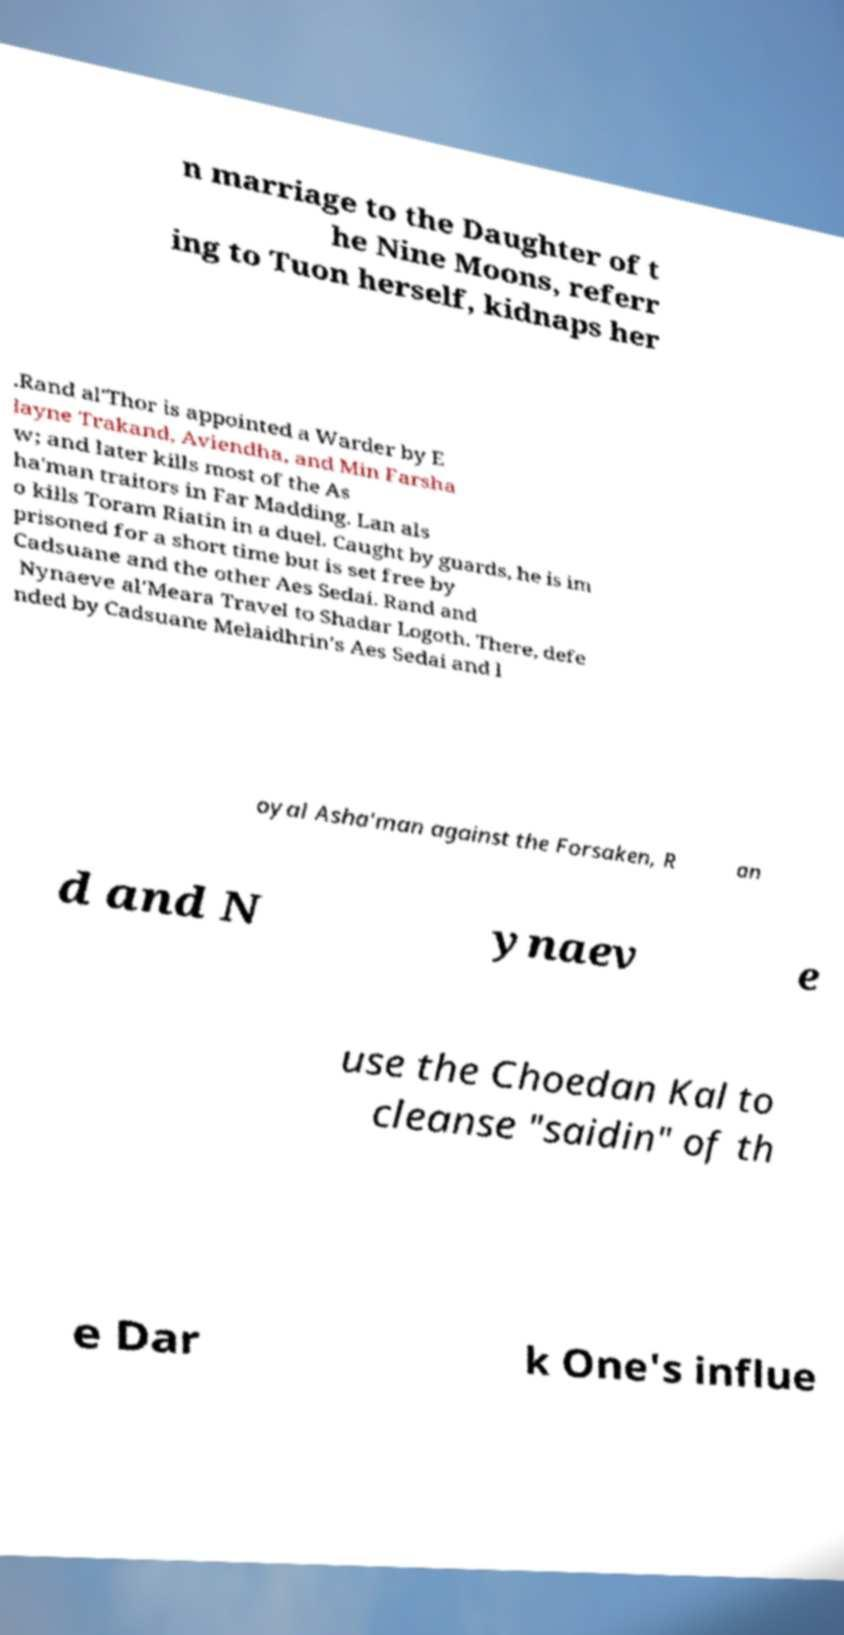Could you assist in decoding the text presented in this image and type it out clearly? n marriage to the Daughter of t he Nine Moons, referr ing to Tuon herself, kidnaps her .Rand al'Thor is appointed a Warder by E layne Trakand, Aviendha, and Min Farsha w; and later kills most of the As ha'man traitors in Far Madding. Lan als o kills Toram Riatin in a duel. Caught by guards, he is im prisoned for a short time but is set free by Cadsuane and the other Aes Sedai. Rand and Nynaeve al'Meara Travel to Shadar Logoth. There, defe nded by Cadsuane Melaidhrin's Aes Sedai and l oyal Asha'man against the Forsaken, R an d and N ynaev e use the Choedan Kal to cleanse "saidin" of th e Dar k One's influe 